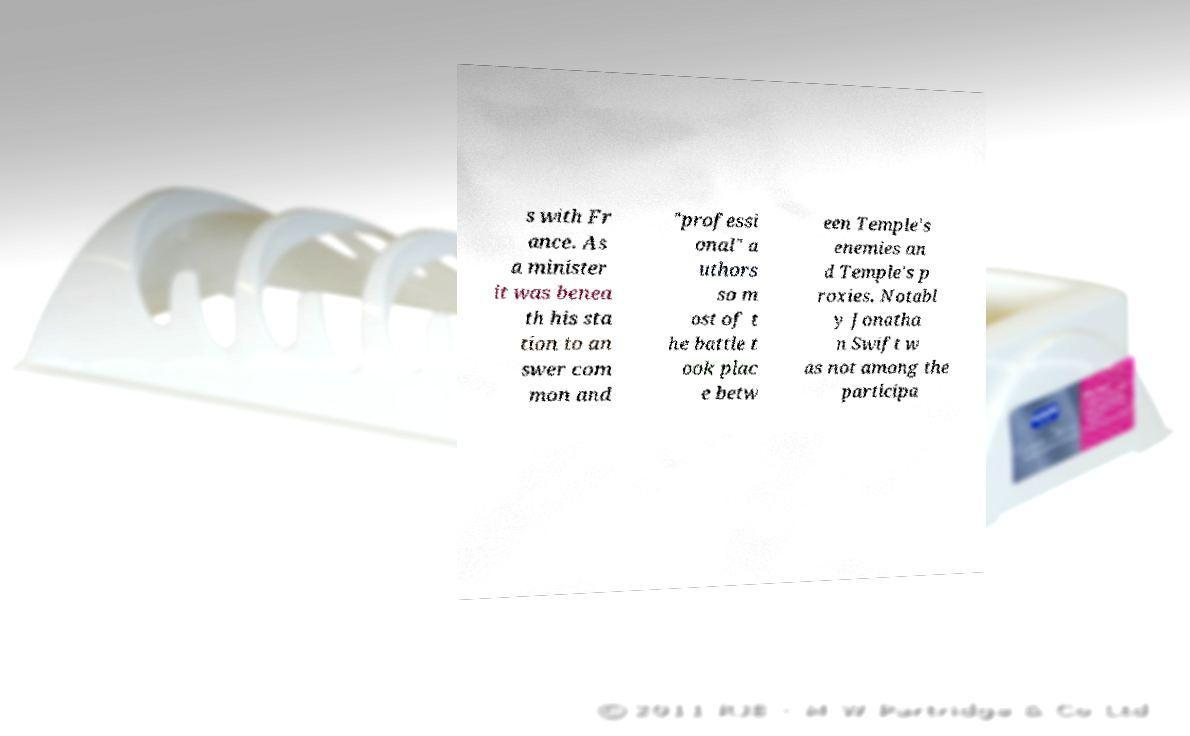What messages or text are displayed in this image? I need them in a readable, typed format. s with Fr ance. As a minister it was benea th his sta tion to an swer com mon and "professi onal" a uthors so m ost of t he battle t ook plac e betw een Temple's enemies an d Temple's p roxies. Notabl y Jonatha n Swift w as not among the participa 